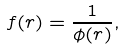Convert formula to latex. <formula><loc_0><loc_0><loc_500><loc_500>f ( r ) = \frac { 1 } { \phi ( r ) } ,</formula> 